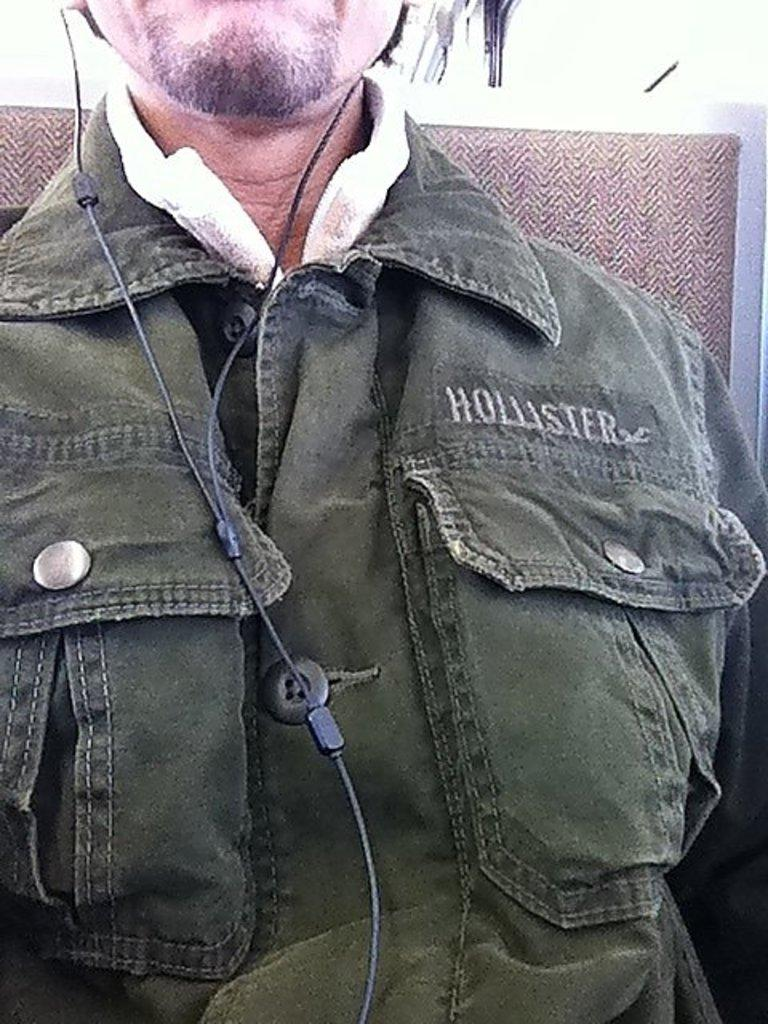Who is the main subject in the image? There is a man in the image. Where is the man positioned in the image? The man is in the front of the image. What is the man wearing in the image? The man is wearing a shirt in the image. What can be seen connected to the man's ears in the image? Earphones are visible in the image. What type of rail can be seen in the image? There is no rail present in the image. 